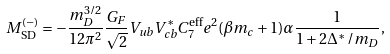<formula> <loc_0><loc_0><loc_500><loc_500>M _ { \text {SD} } ^ { ( - ) } = - \frac { m _ { D } ^ { 3 / 2 } } { 1 2 \pi ^ { 2 } } \frac { G _ { F } } { \sqrt { 2 } } V _ { u b } V _ { c b } ^ { * } C _ { 7 } ^ { \text {eff} } e ^ { 2 } ( \beta m _ { c } + 1 ) \alpha \frac { 1 } { 1 + 2 \Delta ^ { * } / m _ { D } } ,</formula> 